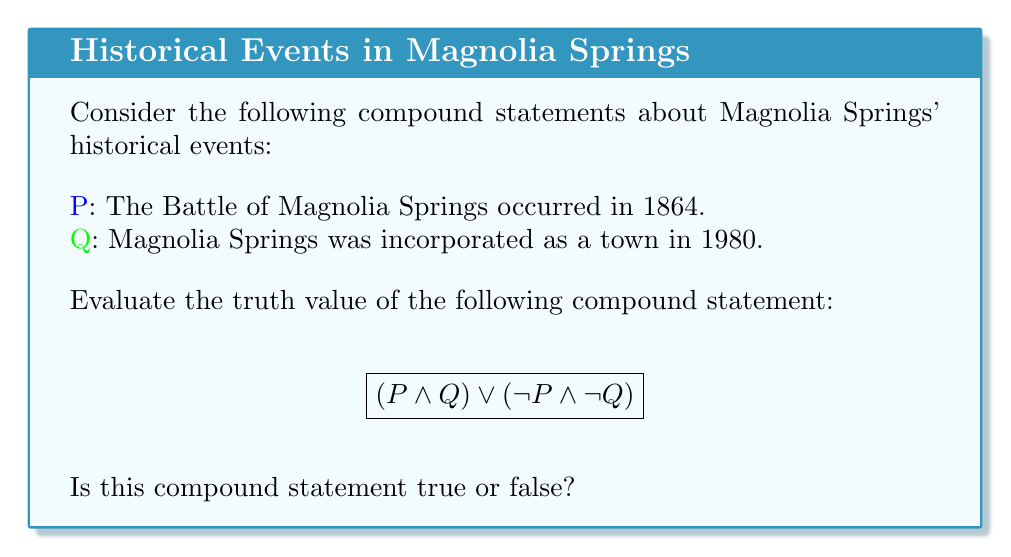Give your solution to this math problem. Let's approach this step-by-step:

1) First, we need to determine the truth values of P and Q individually:

   P: The Battle of Magnolia Springs occurred in 1864.
   This is false. There was no significant battle in Magnolia Springs during the Civil War.

   Q: Magnolia Springs was incorporated as a town in 1980.
   This is false. Magnolia Springs was actually incorporated in 2006.

2) Now, let's evaluate the parts of the compound statement:

   $(P \land Q)$: This is false $\land$ false = false
   $(\lnot P \land \lnot Q)$: This is true $\land$ true = true

3) The compound statement is:

   $$(P \land Q) \lor (\lnot P \land \lnot Q)$$

   Which simplifies to: false $\lor$ true

4) In propositional logic, the $\lor$ (OR) operator returns true if at least one of its operands is true.

5) Since one of the operands (the right side) is true, the entire compound statement evaluates to true.

This type of compound statement, where $(P \land Q) \lor (\lnot P \land \lnot Q)$, is known as a biconditional or "if and only if" statement. It's true when both components have the same truth value (either both true or both false).
Answer: True 